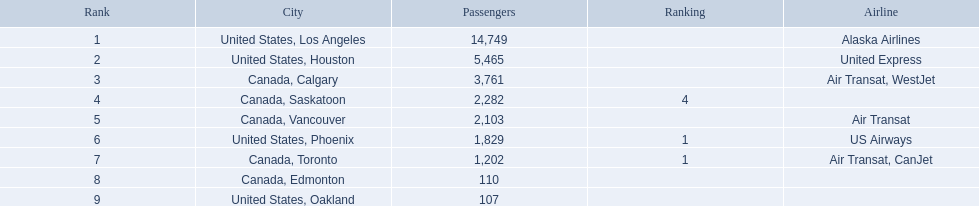Which airport has the fewest passengers? 107. At which airport are there 107 passengers? United States, Oakland. 